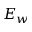Convert formula to latex. <formula><loc_0><loc_0><loc_500><loc_500>E _ { w }</formula> 